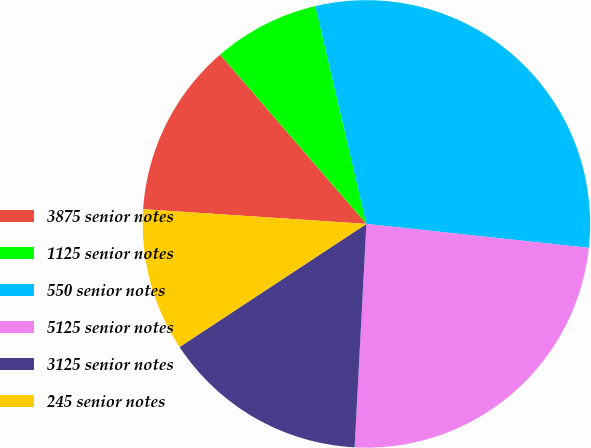Convert chart. <chart><loc_0><loc_0><loc_500><loc_500><pie_chart><fcel>3875 senior notes<fcel>1125 senior notes<fcel>550 senior notes<fcel>5125 senior notes<fcel>3125 senior notes<fcel>245 senior notes<nl><fcel>12.61%<fcel>7.68%<fcel>30.37%<fcel>24.13%<fcel>14.89%<fcel>10.32%<nl></chart> 